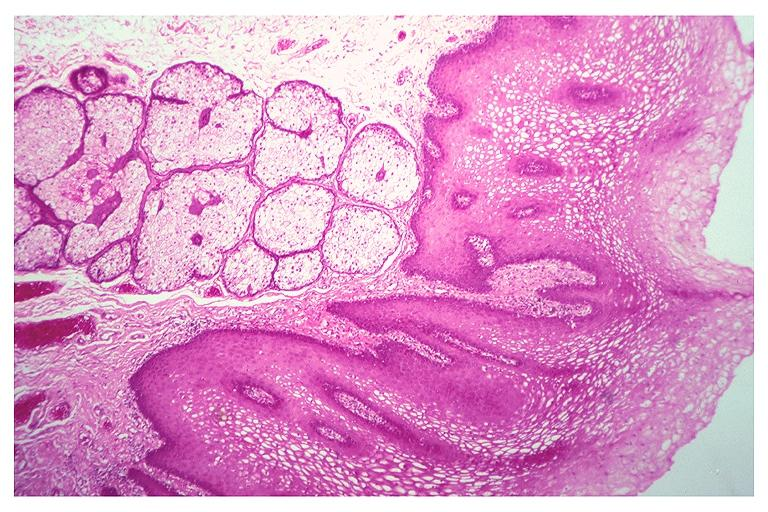s oral present?
Answer the question using a single word or phrase. Yes 